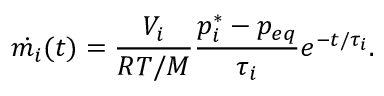<formula> <loc_0><loc_0><loc_500><loc_500>\dot { m _ { i } } ( t ) = \frac { V _ { i } } { R T / M } \frac { p _ { i } ^ { * } - p _ { e q } } { \tau _ { i } } e ^ { - t / \tau _ { i } } .</formula> 